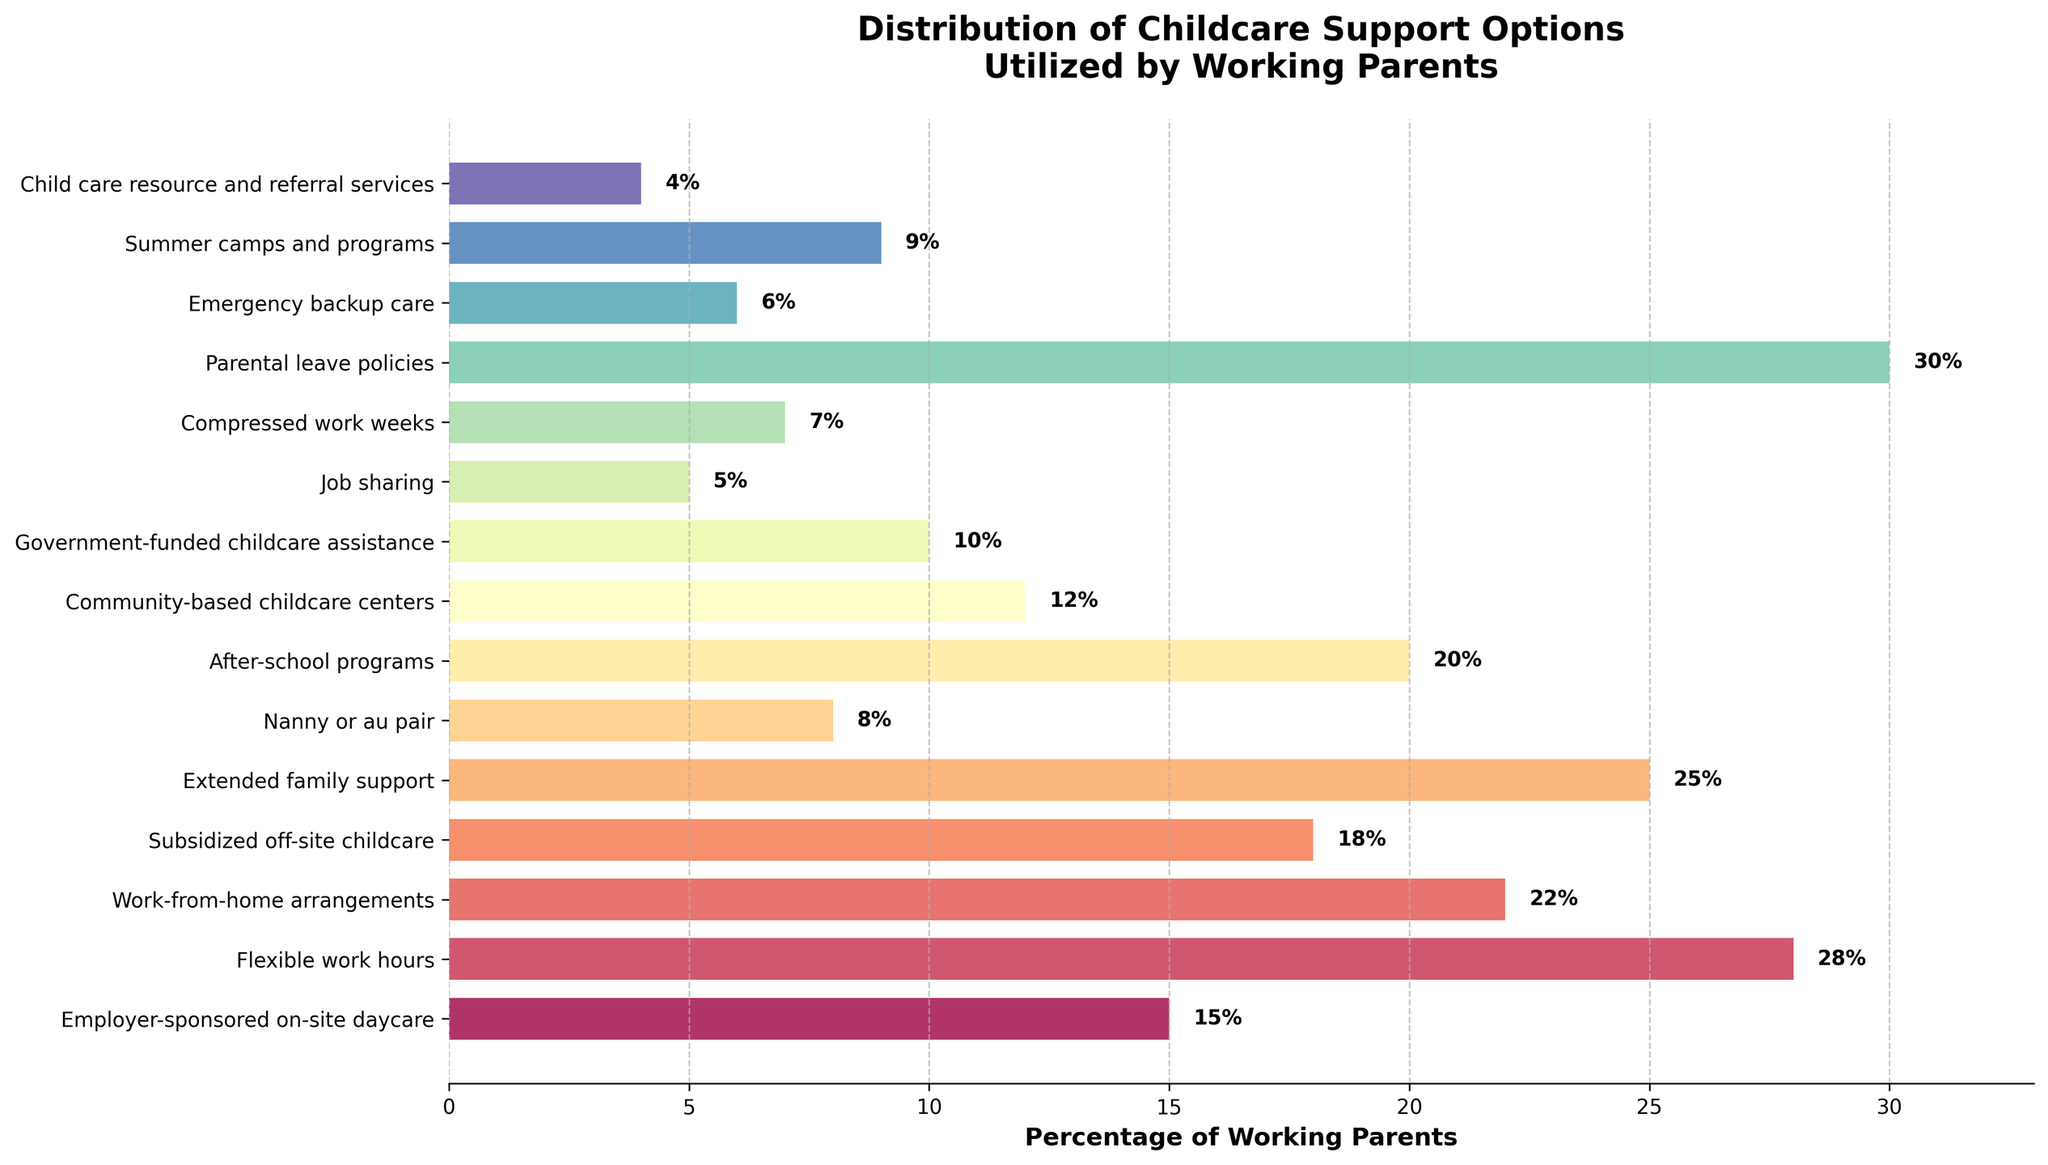Which childcare support option is utilized by the highest percentage of working parents? Parental leave policies show the highest percentage at 30%. This is evident from the length and position of the bar on the horizontal axis.
Answer: Parental leave policies How does the percentage of parents using nanny or au pair compare to those using after-school programs? The percentage of parents using nanny or au pair is 8%, while those utilizing after-school programs are 20%. By comparing the lengths of the bars, after-school programs are more than twice as popular.
Answer: After-school programs are more popular What is the combined percentage of working parents utilizing job sharing and compressed work weeks? Job sharing has a percentage of 5% and compressed work weeks 7%. Adding them together gives 5% + 7% = 12%.
Answer: 12% Which support option has the smallest percentage utilization, and what is that percentage? Child care resource and referral services have the smallest percentage at 4%. This is evident from the shortest bar on the chart.
Answer: Child care resource and referral services, 4% Compare the utilization rates of government-funded childcare assistance and community-based childcare centers. Government-funded childcare assistance is used by 10% of working parents, while community-based childcare centers are used by 12%. The bar for community-based childcare centers is longer, indicating slightly higher utilization.
Answer: Community-based childcare centers are slightly more utilized What percentage of working parents use a support option that includes flexible work hours and work-from-home arrangements? Flexible work hours are used by 28% and work-from-home arrangements by 22%. Their combined usage is 28% + 22% = 50%.
Answer: 50% Is the usage of extended family support greater than or equal to subsidized off-site childcare? Extended family support is at 25% and subsidized off-site childcare is at 18%. Comparing the bar lengths, extended family support is greater.
Answer: Greater What is the average percentage utilization across emergency backup care, summer camps and programs, and job sharing? The individual percentages are 6%, 9%, and 5%. Adding these gives 6% + 9% + 5% = 20%. The average is 20% / 3 = 6.67%.
Answer: 6.67% What difference in the percentage of working parents using work-from-home arrangements and those using parental leave policies? Work-from-home arrangements have a utilization of 22%, while parental leave policies have 30%. The difference is 30% - 22% = 8%.
Answer: 8% Which two support options together have a combined utilization rate closest to 35%? Flexible work hours (28%) combined with emergency backup care (6%) give a total of 34%, which is closest to 35%.
Answer: Flexible work hours and emergency backup care 